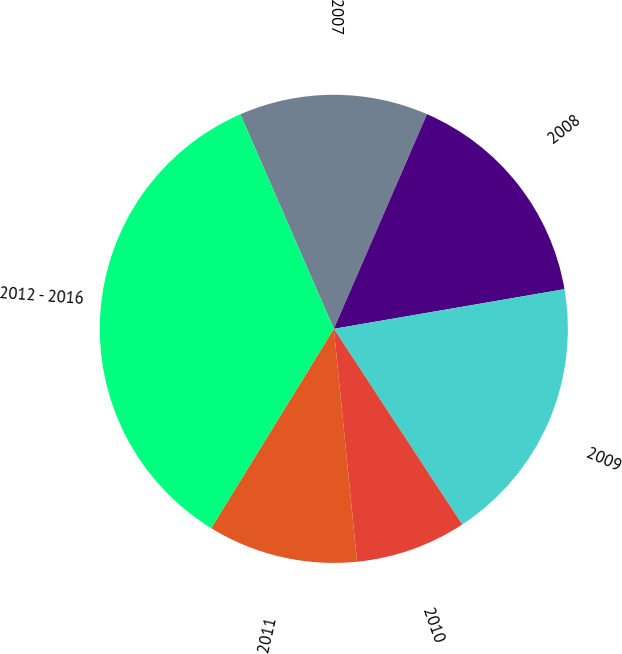Convert chart. <chart><loc_0><loc_0><loc_500><loc_500><pie_chart><fcel>2007<fcel>2008<fcel>2009<fcel>2010<fcel>2011<fcel>2012 - 2016<nl><fcel>13.06%<fcel>15.77%<fcel>18.47%<fcel>7.66%<fcel>10.36%<fcel>34.68%<nl></chart> 